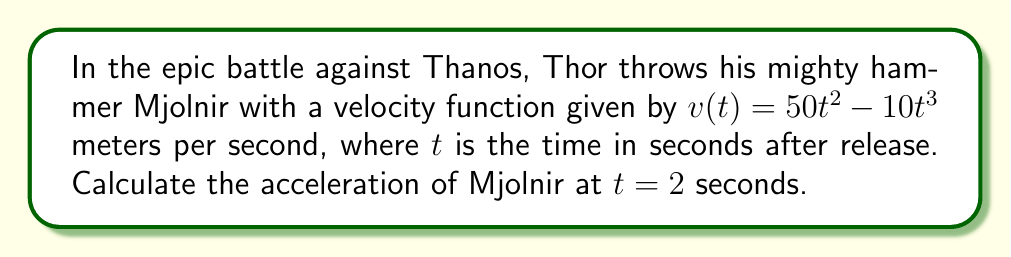Can you solve this math problem? To find the acceleration of Thor's hammer Mjolnir, we need to follow these steps:

1) The velocity function is given as:
   $v(t) = 50t^2 - 10t^3$

2) Acceleration is the derivative of velocity with respect to time. So, we need to find $\frac{dv}{dt}$:

   $a(t) = \frac{dv}{dt} = \frac{d}{dt}(50t^2 - 10t^3)$

3) Using the power rule of differentiation:
   $a(t) = 100t - 30t^2$

4) Now that we have the acceleration function, we can find the acceleration at $t = 2$ seconds:

   $a(2) = 100(2) - 30(2)^2$
   $    = 200 - 30(4)$
   $    = 200 - 120$
   $    = 80$

Therefore, the acceleration of Mjolnir at $t = 2$ seconds is 80 meters per second squared.
Answer: $80 \text{ m/s}^2$ 